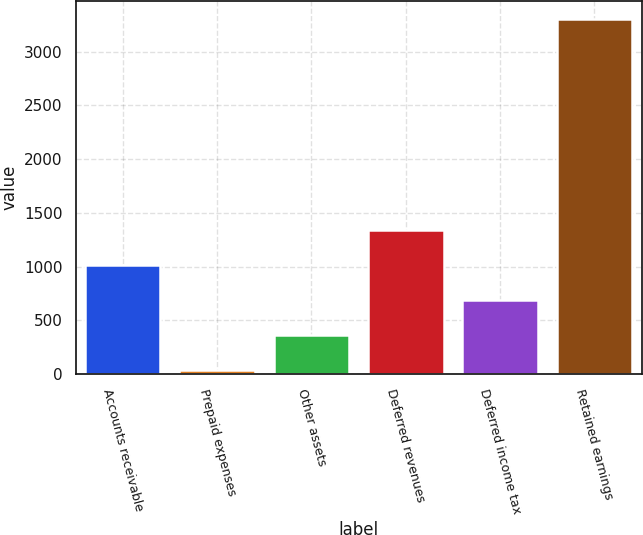Convert chart. <chart><loc_0><loc_0><loc_500><loc_500><bar_chart><fcel>Accounts receivable<fcel>Prepaid expenses<fcel>Other assets<fcel>Deferred revenues<fcel>Deferred income tax<fcel>Retained earnings<nl><fcel>1019.07<fcel>38.1<fcel>365.09<fcel>1346.06<fcel>692.08<fcel>3308<nl></chart> 